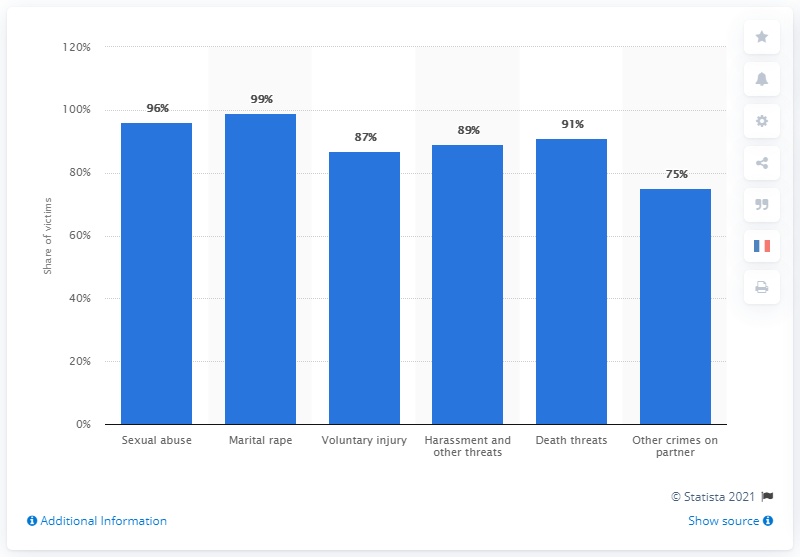Indicate a few pertinent items in this graphic. According to statistics, 99% of marital rape victims were women. 